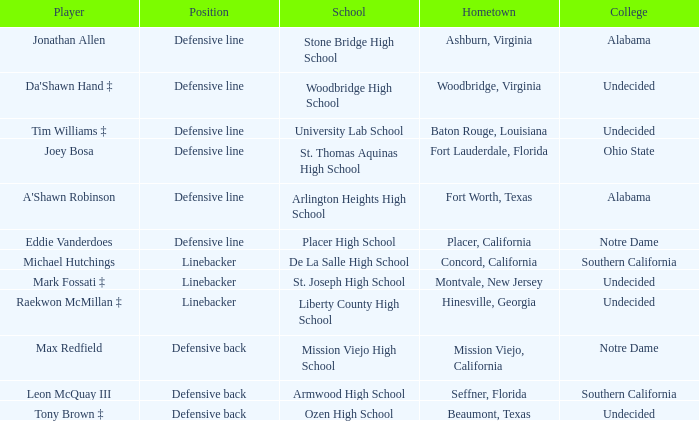What is the position of the player from Beaumont, Texas? Defensive back. 